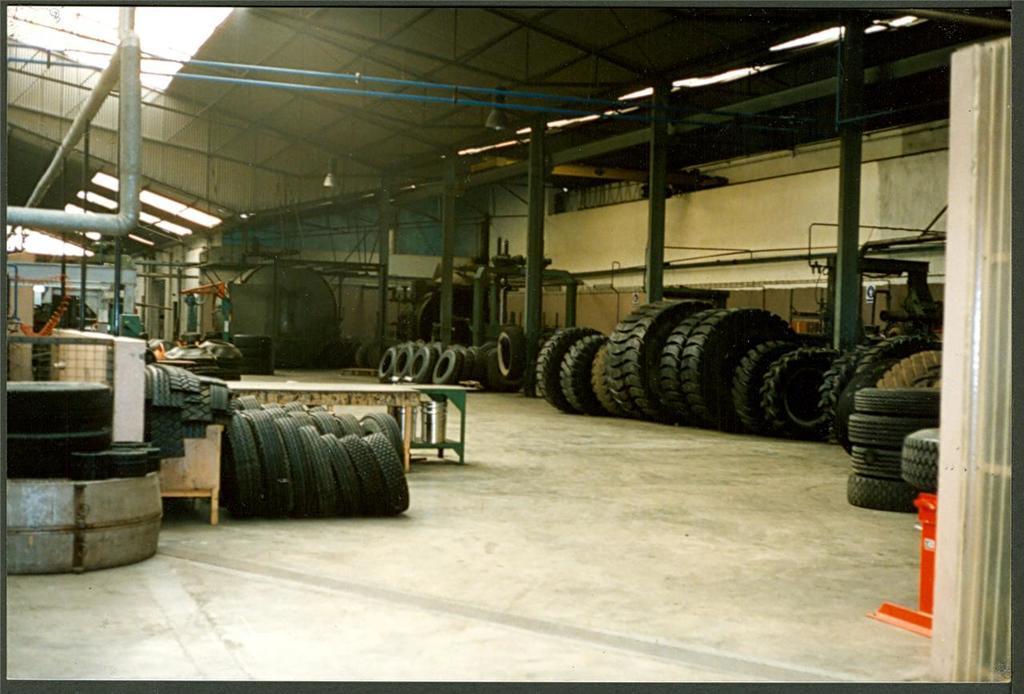Could you give a brief overview of what you see in this image? This is an inner view of a shed. On the left side, there is a pipe, there are tires arranged, a table and other objects. On the right side, there are tires arranged, there are pillars connected to a roof and there is a pipe attached to a wall. In the background, there are buildings and there is sky. 